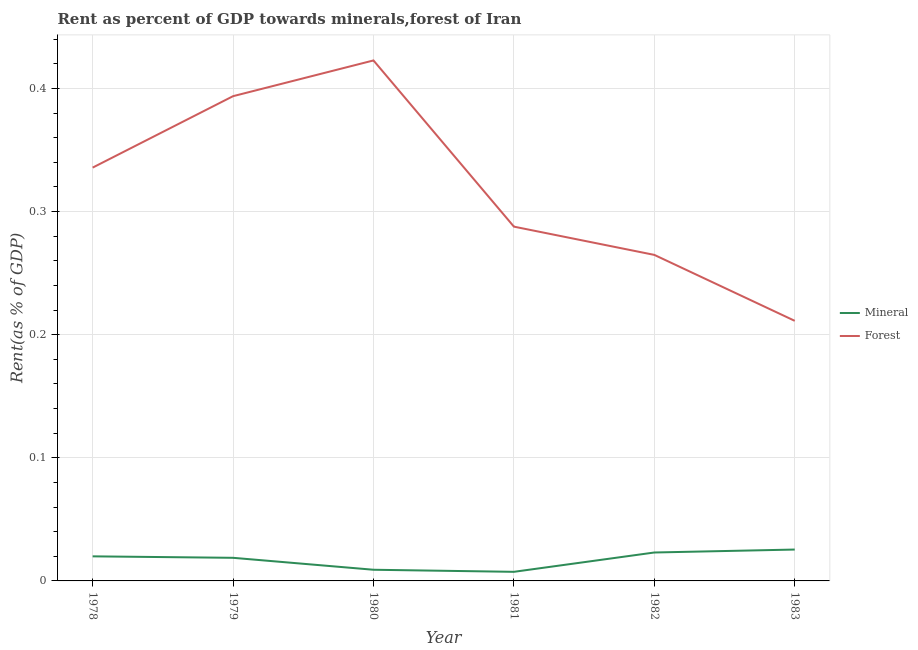Is the number of lines equal to the number of legend labels?
Offer a terse response. Yes. What is the mineral rent in 1979?
Your answer should be very brief. 0.02. Across all years, what is the maximum forest rent?
Make the answer very short. 0.42. Across all years, what is the minimum forest rent?
Provide a short and direct response. 0.21. In which year was the mineral rent maximum?
Ensure brevity in your answer.  1983. In which year was the forest rent minimum?
Make the answer very short. 1983. What is the total forest rent in the graph?
Give a very brief answer. 1.92. What is the difference between the forest rent in 1978 and that in 1981?
Your answer should be very brief. 0.05. What is the difference between the forest rent in 1978 and the mineral rent in 1979?
Give a very brief answer. 0.32. What is the average forest rent per year?
Your answer should be compact. 0.32. In the year 1983, what is the difference between the mineral rent and forest rent?
Your response must be concise. -0.19. In how many years, is the forest rent greater than 0.04 %?
Offer a terse response. 6. What is the ratio of the mineral rent in 1981 to that in 1982?
Your response must be concise. 0.32. Is the difference between the forest rent in 1979 and 1981 greater than the difference between the mineral rent in 1979 and 1981?
Give a very brief answer. Yes. What is the difference between the highest and the second highest forest rent?
Your response must be concise. 0.03. What is the difference between the highest and the lowest forest rent?
Provide a succinct answer. 0.21. Is the mineral rent strictly less than the forest rent over the years?
Make the answer very short. Yes. How many lines are there?
Provide a succinct answer. 2. Where does the legend appear in the graph?
Offer a terse response. Center right. How are the legend labels stacked?
Keep it short and to the point. Vertical. What is the title of the graph?
Provide a short and direct response. Rent as percent of GDP towards minerals,forest of Iran. Does "Manufacturing industries and construction" appear as one of the legend labels in the graph?
Keep it short and to the point. No. What is the label or title of the X-axis?
Provide a succinct answer. Year. What is the label or title of the Y-axis?
Ensure brevity in your answer.  Rent(as % of GDP). What is the Rent(as % of GDP) in Mineral in 1978?
Your response must be concise. 0.02. What is the Rent(as % of GDP) in Forest in 1978?
Offer a very short reply. 0.34. What is the Rent(as % of GDP) in Mineral in 1979?
Your answer should be compact. 0.02. What is the Rent(as % of GDP) in Forest in 1979?
Offer a terse response. 0.39. What is the Rent(as % of GDP) of Mineral in 1980?
Make the answer very short. 0.01. What is the Rent(as % of GDP) in Forest in 1980?
Your response must be concise. 0.42. What is the Rent(as % of GDP) in Mineral in 1981?
Your answer should be very brief. 0.01. What is the Rent(as % of GDP) of Forest in 1981?
Provide a succinct answer. 0.29. What is the Rent(as % of GDP) in Mineral in 1982?
Ensure brevity in your answer.  0.02. What is the Rent(as % of GDP) in Forest in 1982?
Ensure brevity in your answer.  0.26. What is the Rent(as % of GDP) in Mineral in 1983?
Provide a short and direct response. 0.03. What is the Rent(as % of GDP) of Forest in 1983?
Give a very brief answer. 0.21. Across all years, what is the maximum Rent(as % of GDP) in Mineral?
Give a very brief answer. 0.03. Across all years, what is the maximum Rent(as % of GDP) in Forest?
Keep it short and to the point. 0.42. Across all years, what is the minimum Rent(as % of GDP) of Mineral?
Your answer should be compact. 0.01. Across all years, what is the minimum Rent(as % of GDP) in Forest?
Make the answer very short. 0.21. What is the total Rent(as % of GDP) of Mineral in the graph?
Your response must be concise. 0.1. What is the total Rent(as % of GDP) of Forest in the graph?
Offer a very short reply. 1.92. What is the difference between the Rent(as % of GDP) of Mineral in 1978 and that in 1979?
Make the answer very short. 0. What is the difference between the Rent(as % of GDP) in Forest in 1978 and that in 1979?
Your answer should be compact. -0.06. What is the difference between the Rent(as % of GDP) in Mineral in 1978 and that in 1980?
Make the answer very short. 0.01. What is the difference between the Rent(as % of GDP) of Forest in 1978 and that in 1980?
Offer a terse response. -0.09. What is the difference between the Rent(as % of GDP) in Mineral in 1978 and that in 1981?
Offer a terse response. 0.01. What is the difference between the Rent(as % of GDP) of Forest in 1978 and that in 1981?
Make the answer very short. 0.05. What is the difference between the Rent(as % of GDP) of Mineral in 1978 and that in 1982?
Ensure brevity in your answer.  -0. What is the difference between the Rent(as % of GDP) of Forest in 1978 and that in 1982?
Your answer should be compact. 0.07. What is the difference between the Rent(as % of GDP) of Mineral in 1978 and that in 1983?
Your answer should be compact. -0.01. What is the difference between the Rent(as % of GDP) in Forest in 1978 and that in 1983?
Your answer should be very brief. 0.12. What is the difference between the Rent(as % of GDP) of Mineral in 1979 and that in 1980?
Offer a terse response. 0.01. What is the difference between the Rent(as % of GDP) in Forest in 1979 and that in 1980?
Give a very brief answer. -0.03. What is the difference between the Rent(as % of GDP) of Mineral in 1979 and that in 1981?
Offer a terse response. 0.01. What is the difference between the Rent(as % of GDP) of Forest in 1979 and that in 1981?
Provide a short and direct response. 0.11. What is the difference between the Rent(as % of GDP) of Mineral in 1979 and that in 1982?
Your answer should be very brief. -0. What is the difference between the Rent(as % of GDP) of Forest in 1979 and that in 1982?
Ensure brevity in your answer.  0.13. What is the difference between the Rent(as % of GDP) of Mineral in 1979 and that in 1983?
Provide a short and direct response. -0.01. What is the difference between the Rent(as % of GDP) in Forest in 1979 and that in 1983?
Provide a succinct answer. 0.18. What is the difference between the Rent(as % of GDP) of Mineral in 1980 and that in 1981?
Offer a very short reply. 0. What is the difference between the Rent(as % of GDP) of Forest in 1980 and that in 1981?
Offer a terse response. 0.14. What is the difference between the Rent(as % of GDP) of Mineral in 1980 and that in 1982?
Ensure brevity in your answer.  -0.01. What is the difference between the Rent(as % of GDP) in Forest in 1980 and that in 1982?
Ensure brevity in your answer.  0.16. What is the difference between the Rent(as % of GDP) of Mineral in 1980 and that in 1983?
Keep it short and to the point. -0.02. What is the difference between the Rent(as % of GDP) of Forest in 1980 and that in 1983?
Offer a terse response. 0.21. What is the difference between the Rent(as % of GDP) of Mineral in 1981 and that in 1982?
Offer a very short reply. -0.02. What is the difference between the Rent(as % of GDP) in Forest in 1981 and that in 1982?
Give a very brief answer. 0.02. What is the difference between the Rent(as % of GDP) of Mineral in 1981 and that in 1983?
Provide a short and direct response. -0.02. What is the difference between the Rent(as % of GDP) in Forest in 1981 and that in 1983?
Ensure brevity in your answer.  0.08. What is the difference between the Rent(as % of GDP) in Mineral in 1982 and that in 1983?
Offer a very short reply. -0. What is the difference between the Rent(as % of GDP) in Forest in 1982 and that in 1983?
Keep it short and to the point. 0.05. What is the difference between the Rent(as % of GDP) in Mineral in 1978 and the Rent(as % of GDP) in Forest in 1979?
Offer a terse response. -0.37. What is the difference between the Rent(as % of GDP) of Mineral in 1978 and the Rent(as % of GDP) of Forest in 1980?
Offer a very short reply. -0.4. What is the difference between the Rent(as % of GDP) of Mineral in 1978 and the Rent(as % of GDP) of Forest in 1981?
Make the answer very short. -0.27. What is the difference between the Rent(as % of GDP) of Mineral in 1978 and the Rent(as % of GDP) of Forest in 1982?
Your response must be concise. -0.24. What is the difference between the Rent(as % of GDP) of Mineral in 1978 and the Rent(as % of GDP) of Forest in 1983?
Offer a terse response. -0.19. What is the difference between the Rent(as % of GDP) in Mineral in 1979 and the Rent(as % of GDP) in Forest in 1980?
Provide a succinct answer. -0.4. What is the difference between the Rent(as % of GDP) in Mineral in 1979 and the Rent(as % of GDP) in Forest in 1981?
Ensure brevity in your answer.  -0.27. What is the difference between the Rent(as % of GDP) in Mineral in 1979 and the Rent(as % of GDP) in Forest in 1982?
Your answer should be very brief. -0.25. What is the difference between the Rent(as % of GDP) in Mineral in 1979 and the Rent(as % of GDP) in Forest in 1983?
Ensure brevity in your answer.  -0.19. What is the difference between the Rent(as % of GDP) in Mineral in 1980 and the Rent(as % of GDP) in Forest in 1981?
Make the answer very short. -0.28. What is the difference between the Rent(as % of GDP) in Mineral in 1980 and the Rent(as % of GDP) in Forest in 1982?
Offer a very short reply. -0.26. What is the difference between the Rent(as % of GDP) in Mineral in 1980 and the Rent(as % of GDP) in Forest in 1983?
Offer a very short reply. -0.2. What is the difference between the Rent(as % of GDP) of Mineral in 1981 and the Rent(as % of GDP) of Forest in 1982?
Provide a succinct answer. -0.26. What is the difference between the Rent(as % of GDP) in Mineral in 1981 and the Rent(as % of GDP) in Forest in 1983?
Give a very brief answer. -0.2. What is the difference between the Rent(as % of GDP) of Mineral in 1982 and the Rent(as % of GDP) of Forest in 1983?
Make the answer very short. -0.19. What is the average Rent(as % of GDP) in Mineral per year?
Make the answer very short. 0.02. What is the average Rent(as % of GDP) in Forest per year?
Your answer should be very brief. 0.32. In the year 1978, what is the difference between the Rent(as % of GDP) in Mineral and Rent(as % of GDP) in Forest?
Keep it short and to the point. -0.32. In the year 1979, what is the difference between the Rent(as % of GDP) of Mineral and Rent(as % of GDP) of Forest?
Offer a terse response. -0.38. In the year 1980, what is the difference between the Rent(as % of GDP) of Mineral and Rent(as % of GDP) of Forest?
Provide a short and direct response. -0.41. In the year 1981, what is the difference between the Rent(as % of GDP) of Mineral and Rent(as % of GDP) of Forest?
Your answer should be very brief. -0.28. In the year 1982, what is the difference between the Rent(as % of GDP) of Mineral and Rent(as % of GDP) of Forest?
Your answer should be very brief. -0.24. In the year 1983, what is the difference between the Rent(as % of GDP) in Mineral and Rent(as % of GDP) in Forest?
Your answer should be compact. -0.19. What is the ratio of the Rent(as % of GDP) in Mineral in 1978 to that in 1979?
Make the answer very short. 1.06. What is the ratio of the Rent(as % of GDP) in Forest in 1978 to that in 1979?
Keep it short and to the point. 0.85. What is the ratio of the Rent(as % of GDP) of Mineral in 1978 to that in 1980?
Provide a short and direct response. 2.2. What is the ratio of the Rent(as % of GDP) in Forest in 1978 to that in 1980?
Offer a terse response. 0.79. What is the ratio of the Rent(as % of GDP) in Mineral in 1978 to that in 1981?
Your answer should be compact. 2.7. What is the ratio of the Rent(as % of GDP) of Forest in 1978 to that in 1981?
Your answer should be compact. 1.17. What is the ratio of the Rent(as % of GDP) of Mineral in 1978 to that in 1982?
Provide a short and direct response. 0.86. What is the ratio of the Rent(as % of GDP) of Forest in 1978 to that in 1982?
Offer a terse response. 1.27. What is the ratio of the Rent(as % of GDP) of Mineral in 1978 to that in 1983?
Give a very brief answer. 0.78. What is the ratio of the Rent(as % of GDP) in Forest in 1978 to that in 1983?
Ensure brevity in your answer.  1.59. What is the ratio of the Rent(as % of GDP) of Mineral in 1979 to that in 1980?
Offer a very short reply. 2.07. What is the ratio of the Rent(as % of GDP) in Forest in 1979 to that in 1980?
Offer a terse response. 0.93. What is the ratio of the Rent(as % of GDP) in Mineral in 1979 to that in 1981?
Give a very brief answer. 2.54. What is the ratio of the Rent(as % of GDP) of Forest in 1979 to that in 1981?
Ensure brevity in your answer.  1.37. What is the ratio of the Rent(as % of GDP) in Mineral in 1979 to that in 1982?
Offer a very short reply. 0.81. What is the ratio of the Rent(as % of GDP) of Forest in 1979 to that in 1982?
Your response must be concise. 1.49. What is the ratio of the Rent(as % of GDP) in Mineral in 1979 to that in 1983?
Offer a terse response. 0.74. What is the ratio of the Rent(as % of GDP) of Forest in 1979 to that in 1983?
Make the answer very short. 1.86. What is the ratio of the Rent(as % of GDP) of Mineral in 1980 to that in 1981?
Keep it short and to the point. 1.23. What is the ratio of the Rent(as % of GDP) in Forest in 1980 to that in 1981?
Ensure brevity in your answer.  1.47. What is the ratio of the Rent(as % of GDP) of Mineral in 1980 to that in 1982?
Give a very brief answer. 0.39. What is the ratio of the Rent(as % of GDP) in Forest in 1980 to that in 1982?
Provide a short and direct response. 1.6. What is the ratio of the Rent(as % of GDP) of Mineral in 1980 to that in 1983?
Offer a terse response. 0.36. What is the ratio of the Rent(as % of GDP) of Forest in 1980 to that in 1983?
Offer a very short reply. 2. What is the ratio of the Rent(as % of GDP) of Mineral in 1981 to that in 1982?
Make the answer very short. 0.32. What is the ratio of the Rent(as % of GDP) in Forest in 1981 to that in 1982?
Your response must be concise. 1.09. What is the ratio of the Rent(as % of GDP) in Mineral in 1981 to that in 1983?
Offer a terse response. 0.29. What is the ratio of the Rent(as % of GDP) of Forest in 1981 to that in 1983?
Your answer should be compact. 1.36. What is the ratio of the Rent(as % of GDP) of Mineral in 1982 to that in 1983?
Offer a very short reply. 0.91. What is the ratio of the Rent(as % of GDP) in Forest in 1982 to that in 1983?
Your response must be concise. 1.25. What is the difference between the highest and the second highest Rent(as % of GDP) in Mineral?
Ensure brevity in your answer.  0. What is the difference between the highest and the second highest Rent(as % of GDP) in Forest?
Provide a succinct answer. 0.03. What is the difference between the highest and the lowest Rent(as % of GDP) of Mineral?
Make the answer very short. 0.02. What is the difference between the highest and the lowest Rent(as % of GDP) in Forest?
Your answer should be compact. 0.21. 